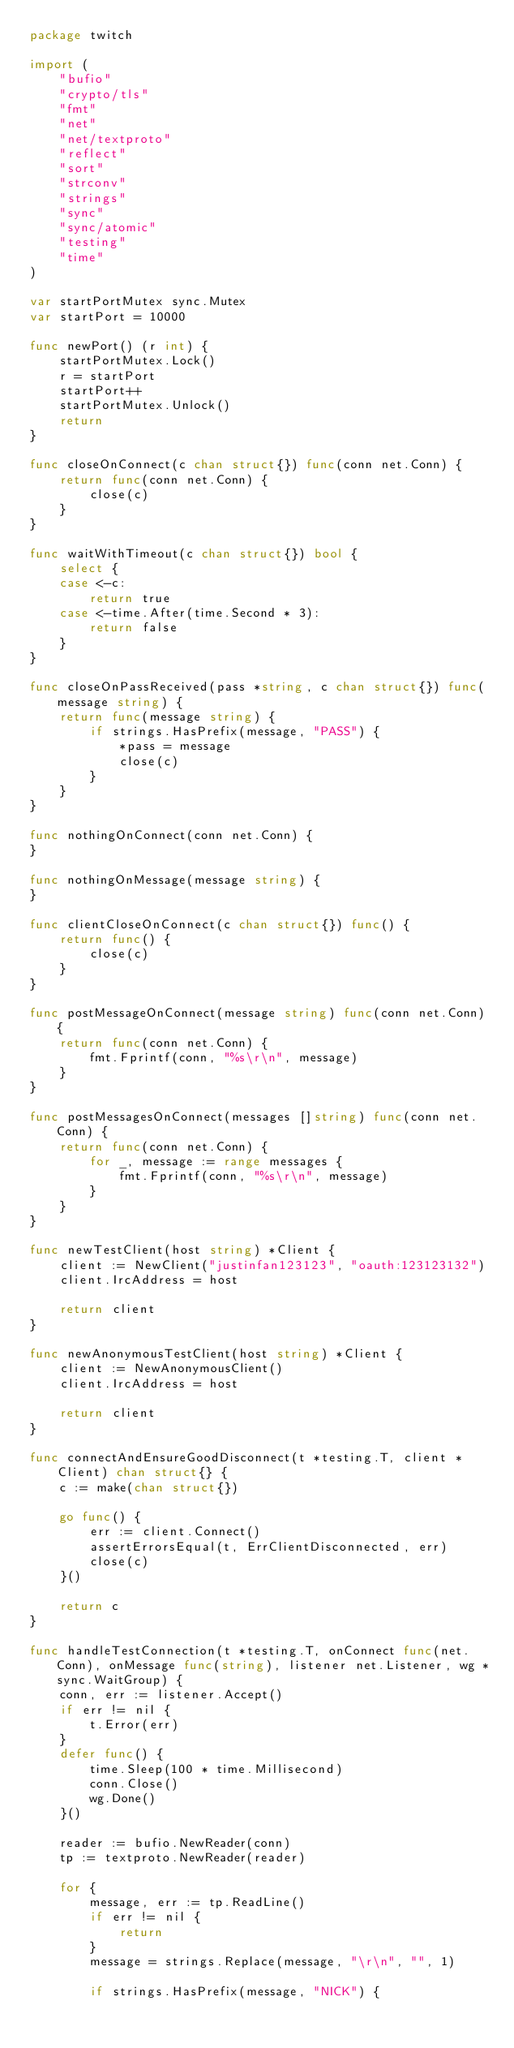Convert code to text. <code><loc_0><loc_0><loc_500><loc_500><_Go_>package twitch

import (
	"bufio"
	"crypto/tls"
	"fmt"
	"net"
	"net/textproto"
	"reflect"
	"sort"
	"strconv"
	"strings"
	"sync"
	"sync/atomic"
	"testing"
	"time"
)

var startPortMutex sync.Mutex
var startPort = 10000

func newPort() (r int) {
	startPortMutex.Lock()
	r = startPort
	startPort++
	startPortMutex.Unlock()
	return
}

func closeOnConnect(c chan struct{}) func(conn net.Conn) {
	return func(conn net.Conn) {
		close(c)
	}
}

func waitWithTimeout(c chan struct{}) bool {
	select {
	case <-c:
		return true
	case <-time.After(time.Second * 3):
		return false
	}
}

func closeOnPassReceived(pass *string, c chan struct{}) func(message string) {
	return func(message string) {
		if strings.HasPrefix(message, "PASS") {
			*pass = message
			close(c)
		}
	}
}

func nothingOnConnect(conn net.Conn) {
}

func nothingOnMessage(message string) {
}

func clientCloseOnConnect(c chan struct{}) func() {
	return func() {
		close(c)
	}
}

func postMessageOnConnect(message string) func(conn net.Conn) {
	return func(conn net.Conn) {
		fmt.Fprintf(conn, "%s\r\n", message)
	}
}

func postMessagesOnConnect(messages []string) func(conn net.Conn) {
	return func(conn net.Conn) {
		for _, message := range messages {
			fmt.Fprintf(conn, "%s\r\n", message)
		}
	}
}

func newTestClient(host string) *Client {
	client := NewClient("justinfan123123", "oauth:123123132")
	client.IrcAddress = host

	return client
}

func newAnonymousTestClient(host string) *Client {
	client := NewAnonymousClient()
	client.IrcAddress = host

	return client
}

func connectAndEnsureGoodDisconnect(t *testing.T, client *Client) chan struct{} {
	c := make(chan struct{})

	go func() {
		err := client.Connect()
		assertErrorsEqual(t, ErrClientDisconnected, err)
		close(c)
	}()

	return c
}

func handleTestConnection(t *testing.T, onConnect func(net.Conn), onMessage func(string), listener net.Listener, wg *sync.WaitGroup) {
	conn, err := listener.Accept()
	if err != nil {
		t.Error(err)
	}
	defer func() {
		time.Sleep(100 * time.Millisecond)
		conn.Close()
		wg.Done()
	}()

	reader := bufio.NewReader(conn)
	tp := textproto.NewReader(reader)

	for {
		message, err := tp.ReadLine()
		if err != nil {
			return
		}
		message = strings.Replace(message, "\r\n", "", 1)

		if strings.HasPrefix(message, "NICK") {</code> 